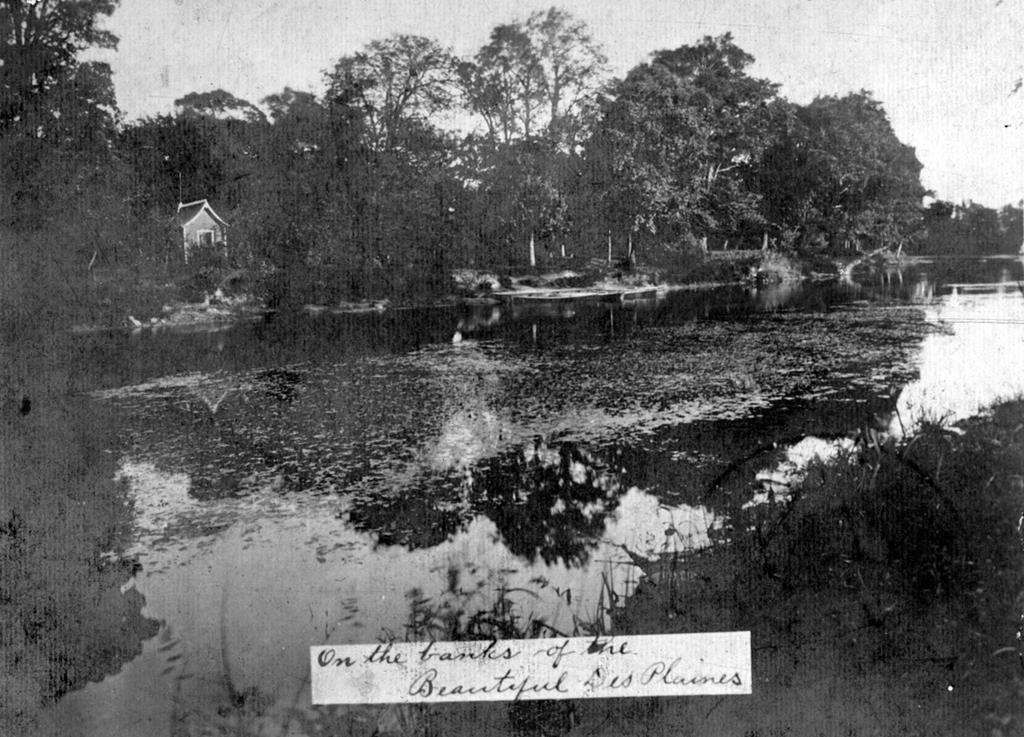What is the color scheme of the image? The image is black and white. What natural element can be seen in the image? There is water visible in the image. What type of structure is present in the image? There is a house in the image. What type of vegetation is present in the image? There are plants and trees in the image. What is visible in the background of the image? The sky is visible in the background of the image. Are there any textual elements in the image? Yes, there are letters on the image. What type of agreement is being discussed in the image? There is no discussion or agreement present in the image; it is a black and white image featuring a house, water, plants, trees, the sky, and letters. What class of students is depicted in the image? There are no students or classes present in the image. 